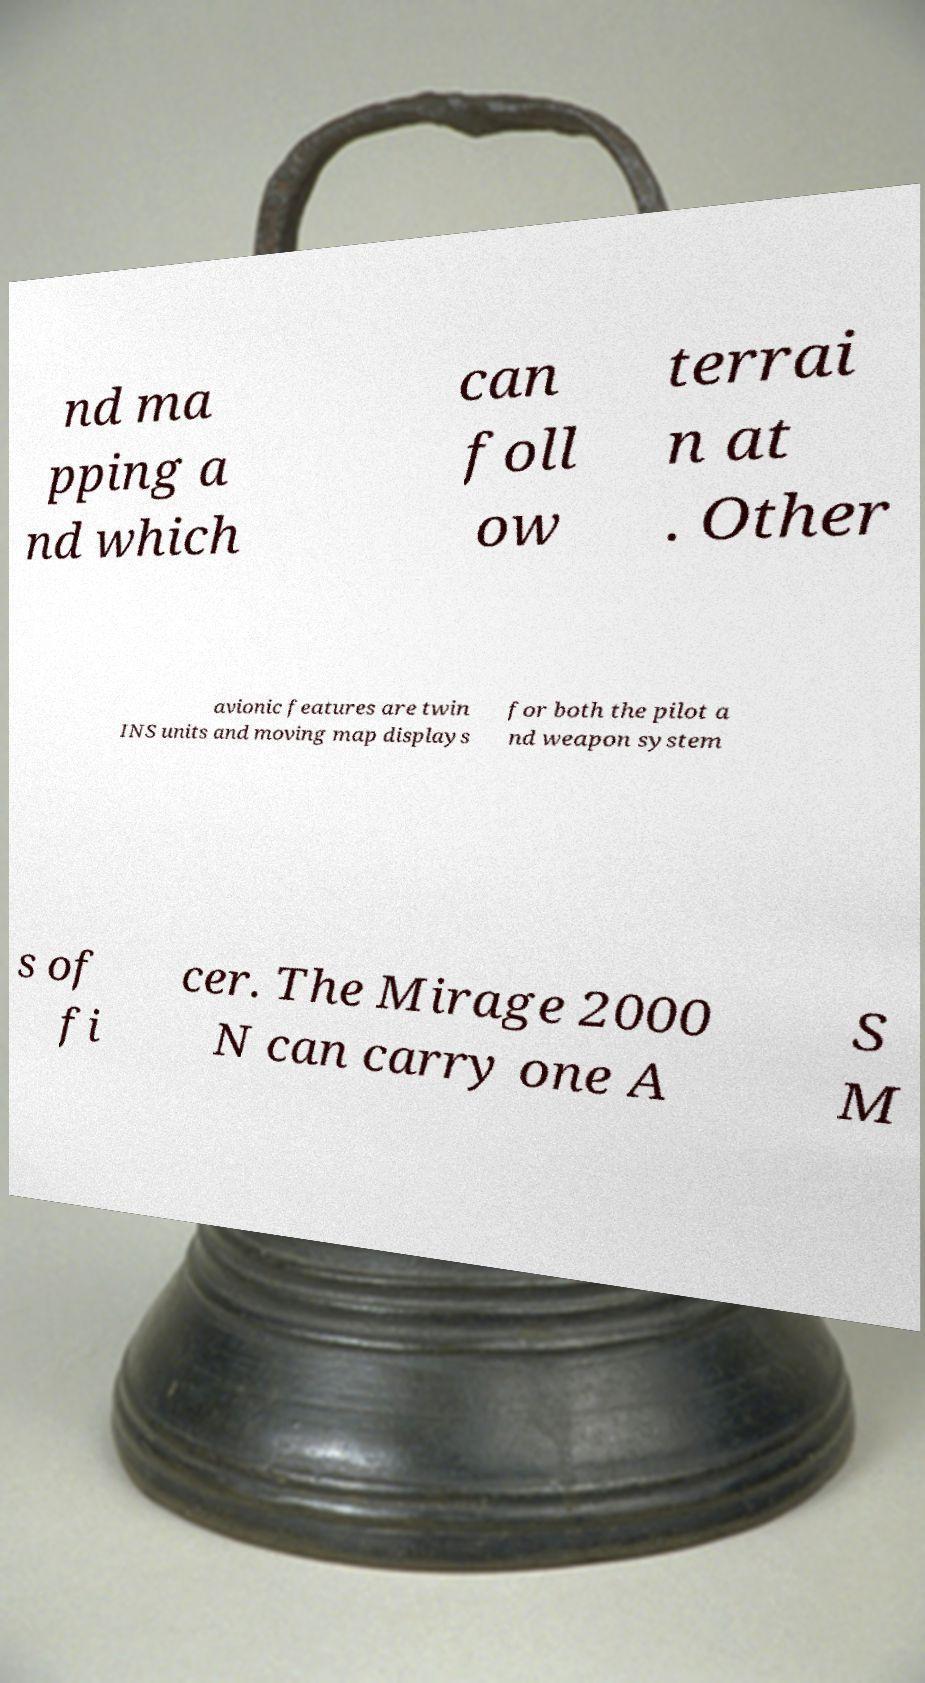For documentation purposes, I need the text within this image transcribed. Could you provide that? nd ma pping a nd which can foll ow terrai n at . Other avionic features are twin INS units and moving map displays for both the pilot a nd weapon system s of fi cer. The Mirage 2000 N can carry one A S M 